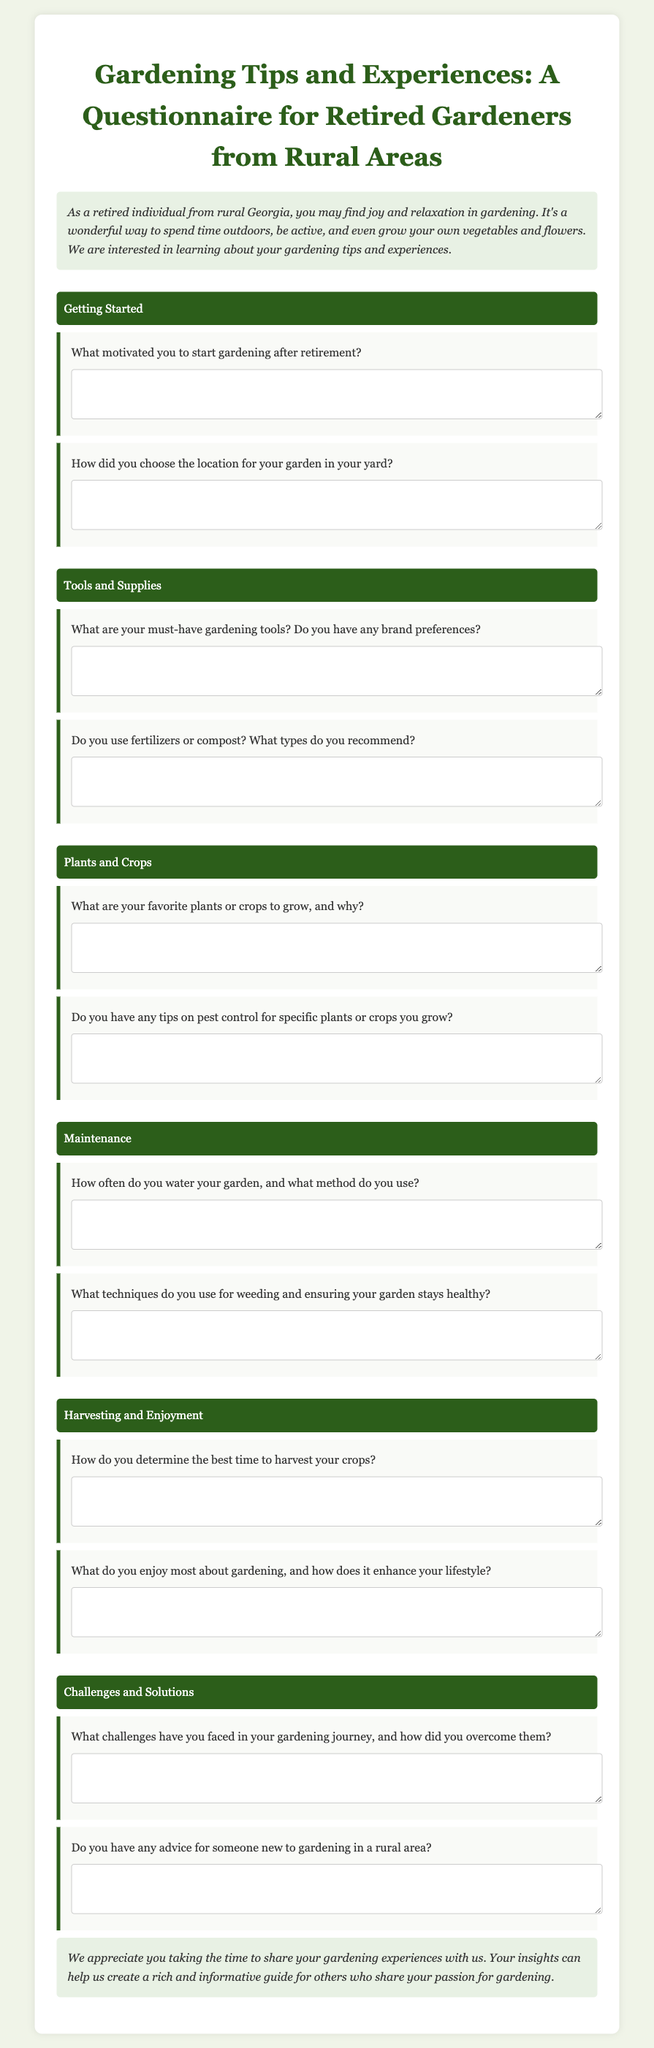What is the title of the questionnaire? The title can be found at the beginning of the document, summarizing its focus and audience.
Answer: Gardening Tips and Experiences: A Questionnaire for Retired Gardeners from Rural Areas How many categories are there in the questionnaire? The document outlines specific sections, each dedicated to a different aspect of gardening.
Answer: Six What are the first two categories listed in the questionnaire? The categories are labeled clearly; the first two guide the respondent regarding initial steps in gardening.
Answer: Getting Started, Tools and Supplies What is one question related to plants or crops? The document specifies questions pertaining to different gardening topics, including plants and crops.
Answer: What are your favorite plants or crops to grow, and why? What does the introduction suggest about gardening? The introduction provides insights into the benefits and joys of gardening for the target audience.
Answer: A way to spend time outdoors, be active, and grow your own vegetables and flowers What is mentioned about weeding in the maintenance section? The maintenance category includes questions about techniques for keeping the garden healthy, specifically regarding weeding.
Answer: What techniques do you use for weeding and ensuring your garden stays healthy? 